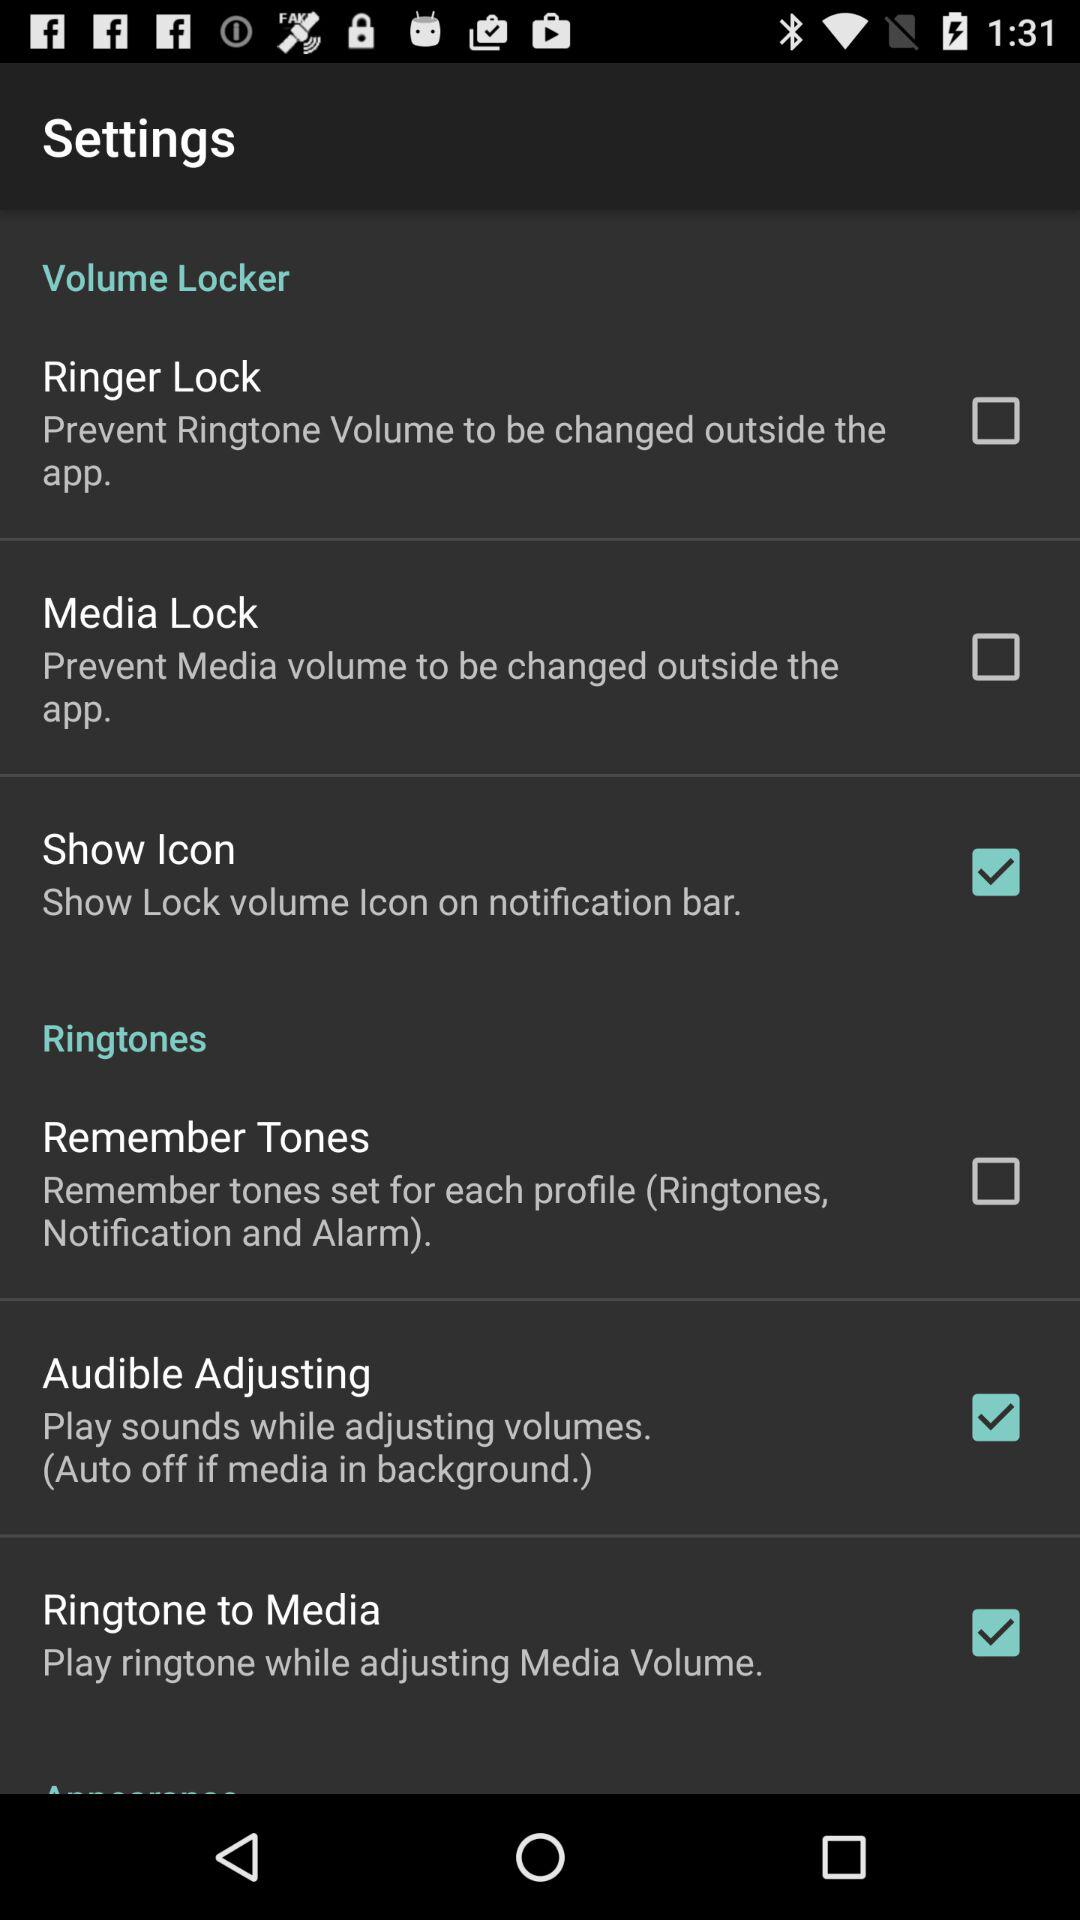What is the current status of "Remember Tones"? The current status of "Remember Tones" is "off". 